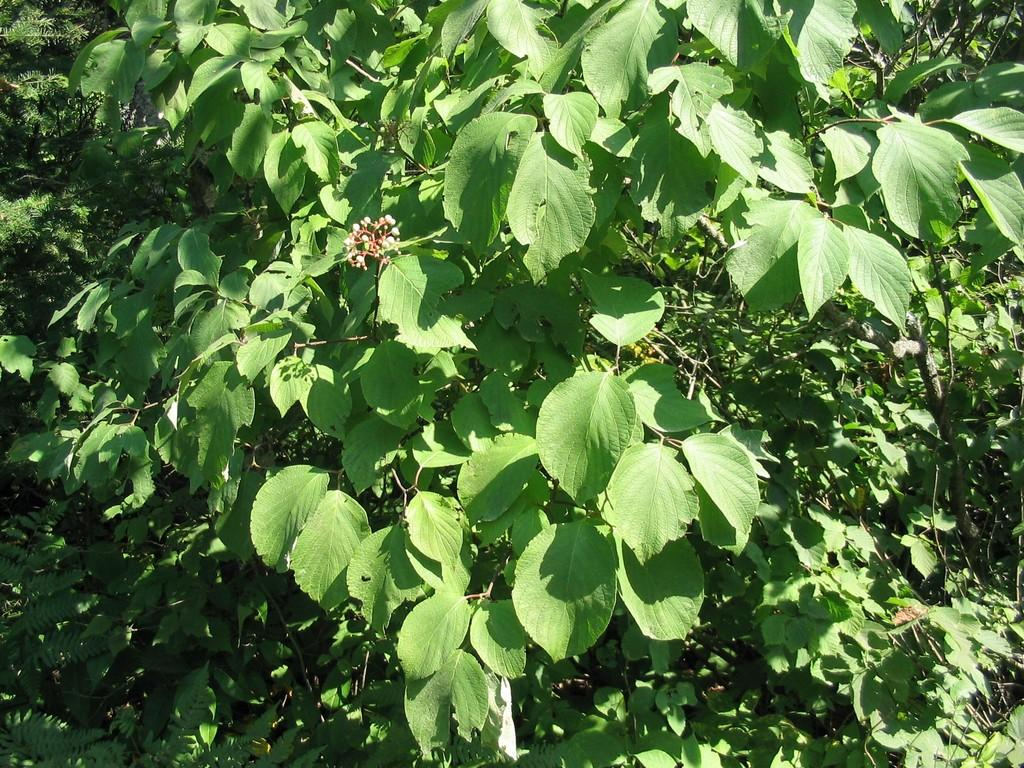What types of living organisms can be seen in the image? Plants of different kinds can be seen in the image. Can you describe the variety of plants in the image? The image contains plants of different kinds, but specific details about each plant are not provided. What is the setting or environment in which the plants are located? The information provided does not specify the setting or environment of the plants. What type of spoon is being used to pay off the debt in the image? There is no spoon or debt present in the image; it only contains plants of different kinds. 